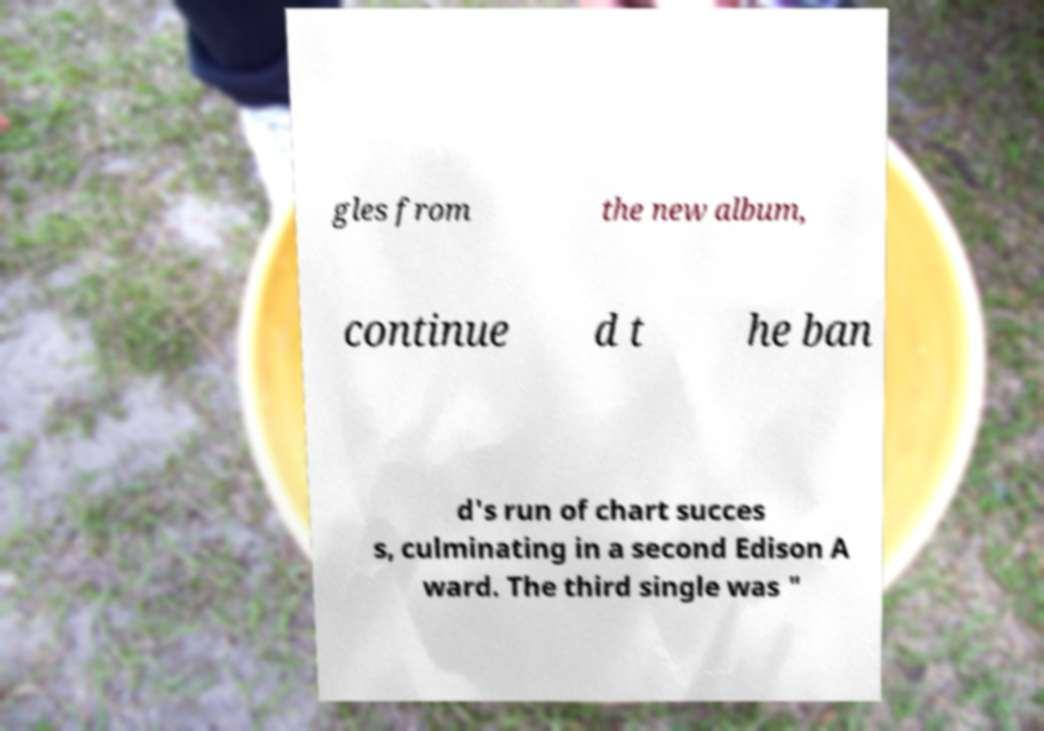What messages or text are displayed in this image? I need them in a readable, typed format. gles from the new album, continue d t he ban d's run of chart succes s, culminating in a second Edison A ward. The third single was " 